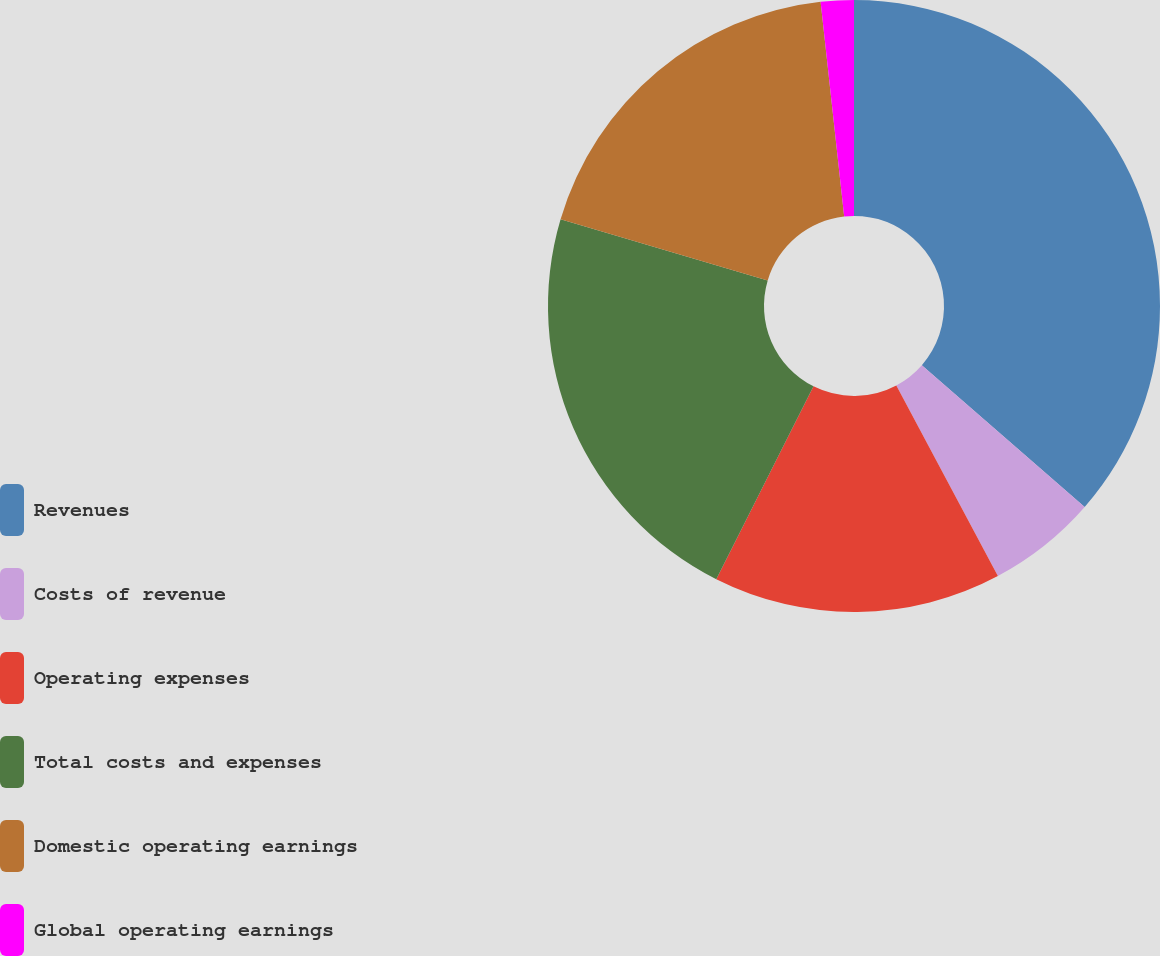Convert chart. <chart><loc_0><loc_0><loc_500><loc_500><pie_chart><fcel>Revenues<fcel>Costs of revenue<fcel>Operating expenses<fcel>Total costs and expenses<fcel>Domestic operating earnings<fcel>Global operating earnings<nl><fcel>36.41%<fcel>5.8%<fcel>15.22%<fcel>22.15%<fcel>18.68%<fcel>1.74%<nl></chart> 